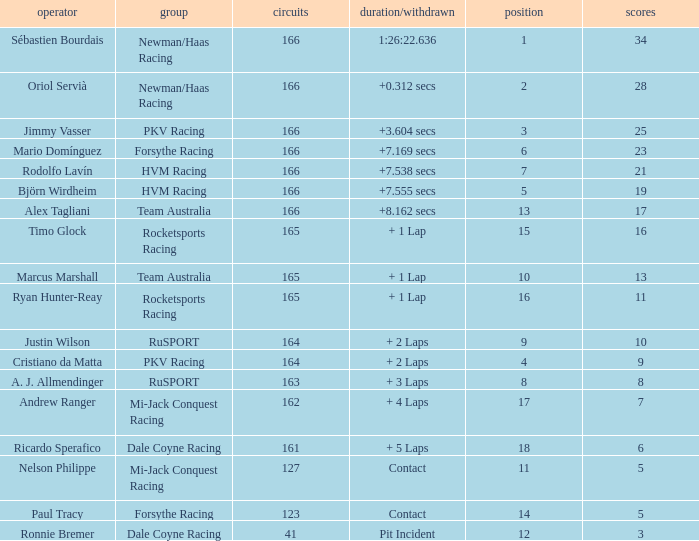Driver Ricardo Sperafico has what as his average laps? 161.0. 